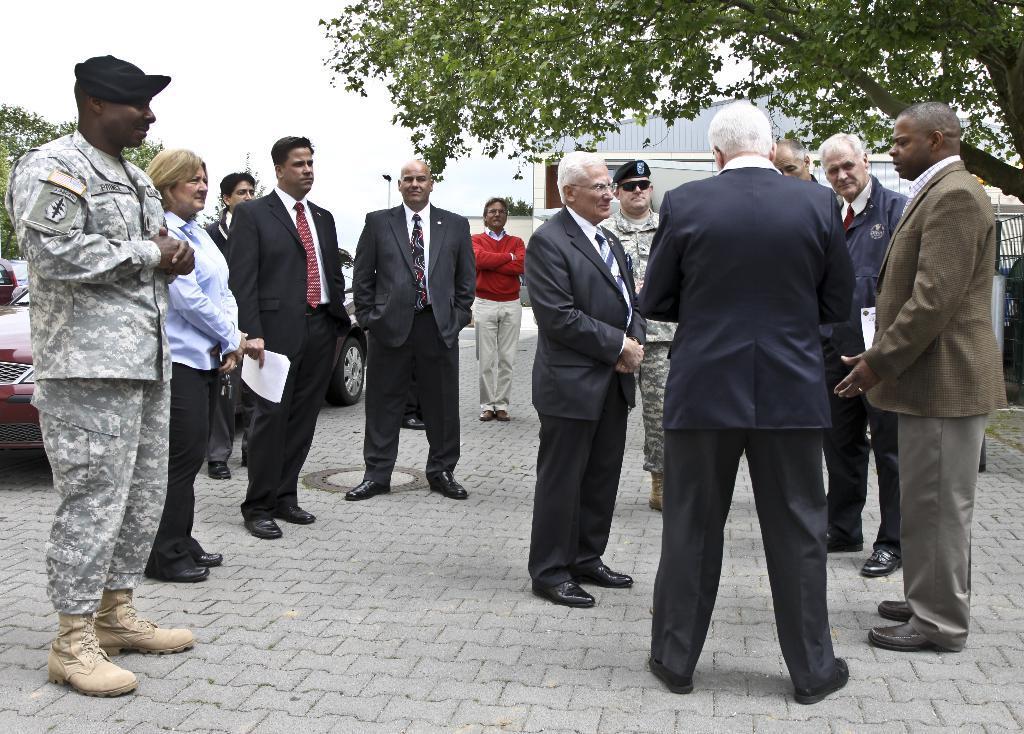Can you describe this image briefly? In this picture I can see few people are standing and I can see a woman holding a paper. I can see cars on the left side and a building in the back and I can see trees and a cloudy sky. 